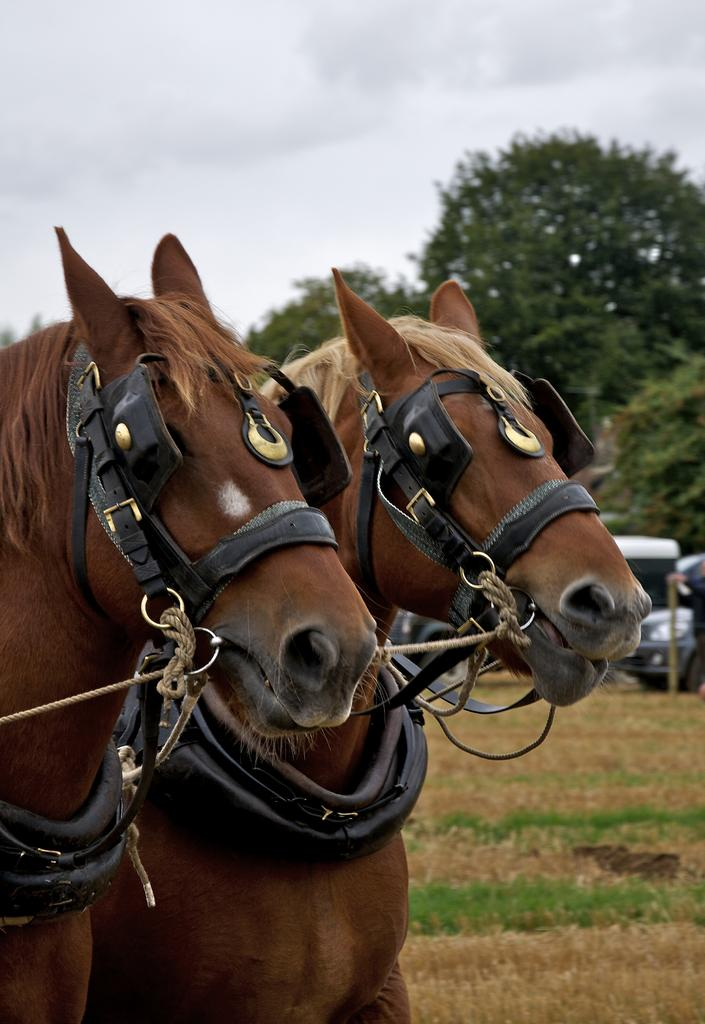How many horses are in the image? There are two horses in the image. What can be seen beneath the horses in the image? The ground is visible in the image. What type of man-made object is present in the image? There is a vehicle in the image. What type of natural scenery is visible in the background of the image? There are trees in the background of the image. What part of the natural environment is visible in the background of the image? The sky is visible in the background of the image. Where is the playground located in the image? There is no playground present in the image. What type of pigs can be seen playing with the horses in the image? There are no pigs present in the image, and the horses are not engaged in play. 